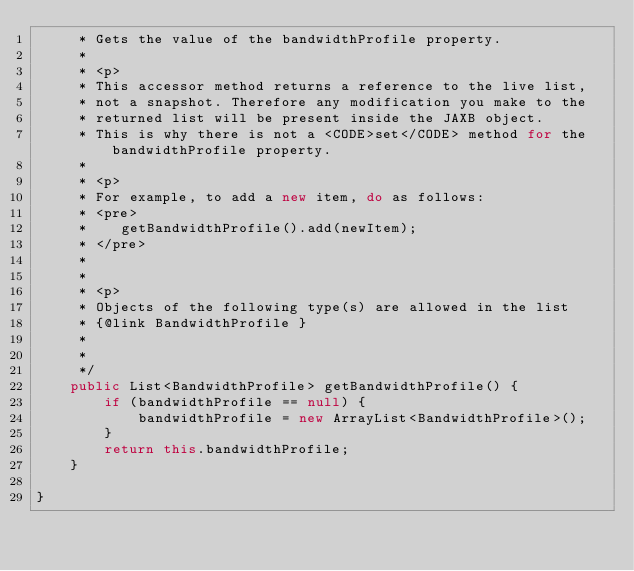Convert code to text. <code><loc_0><loc_0><loc_500><loc_500><_Java_>     * Gets the value of the bandwidthProfile property.
     * 
     * <p>
     * This accessor method returns a reference to the live list,
     * not a snapshot. Therefore any modification you make to the
     * returned list will be present inside the JAXB object.
     * This is why there is not a <CODE>set</CODE> method for the bandwidthProfile property.
     * 
     * <p>
     * For example, to add a new item, do as follows:
     * <pre>
     *    getBandwidthProfile().add(newItem);
     * </pre>
     * 
     * 
     * <p>
     * Objects of the following type(s) are allowed in the list
     * {@link BandwidthProfile }
     * 
     * 
     */
    public List<BandwidthProfile> getBandwidthProfile() {
        if (bandwidthProfile == null) {
            bandwidthProfile = new ArrayList<BandwidthProfile>();
        }
        return this.bandwidthProfile;
    }

}
</code> 